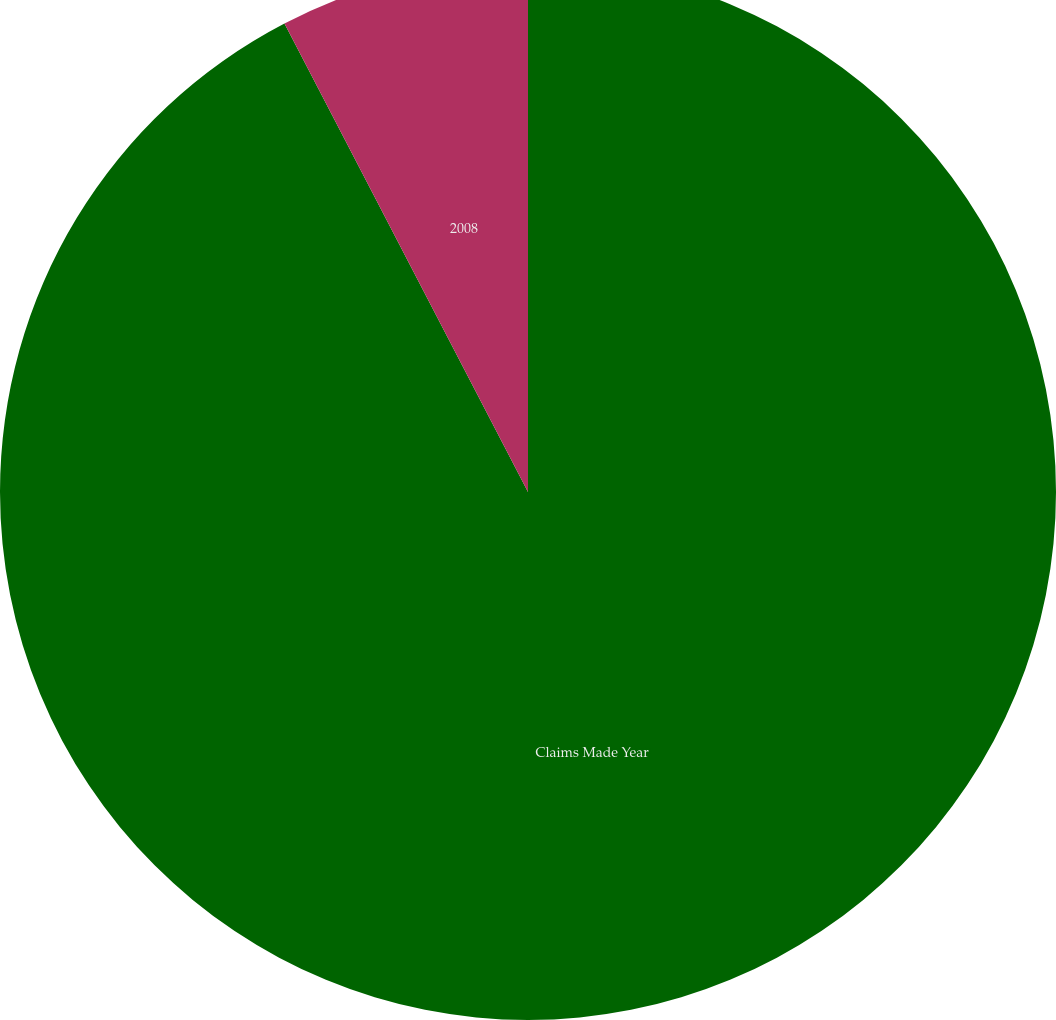<chart> <loc_0><loc_0><loc_500><loc_500><pie_chart><fcel>Claims Made Year<fcel>2008<nl><fcel>92.37%<fcel>7.63%<nl></chart> 